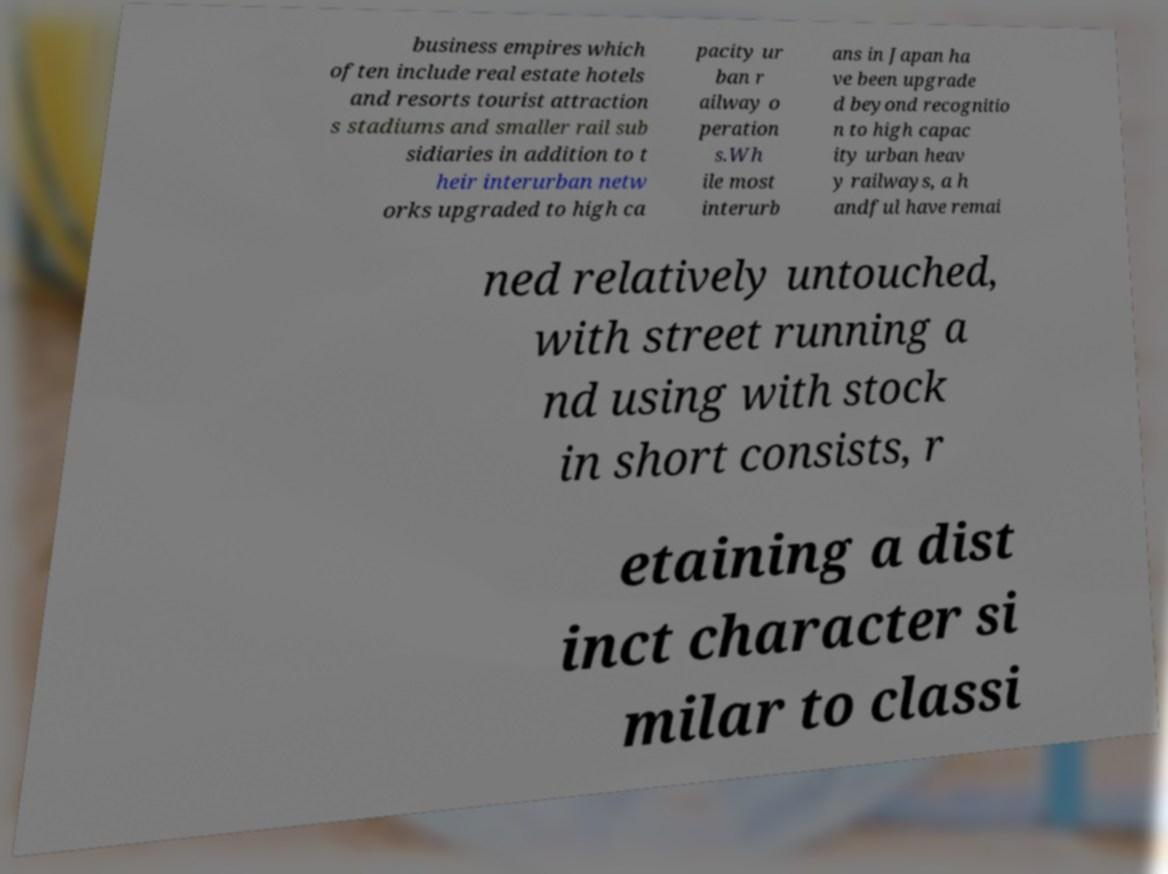Please read and relay the text visible in this image. What does it say? business empires which often include real estate hotels and resorts tourist attraction s stadiums and smaller rail sub sidiaries in addition to t heir interurban netw orks upgraded to high ca pacity ur ban r ailway o peration s.Wh ile most interurb ans in Japan ha ve been upgrade d beyond recognitio n to high capac ity urban heav y railways, a h andful have remai ned relatively untouched, with street running a nd using with stock in short consists, r etaining a dist inct character si milar to classi 